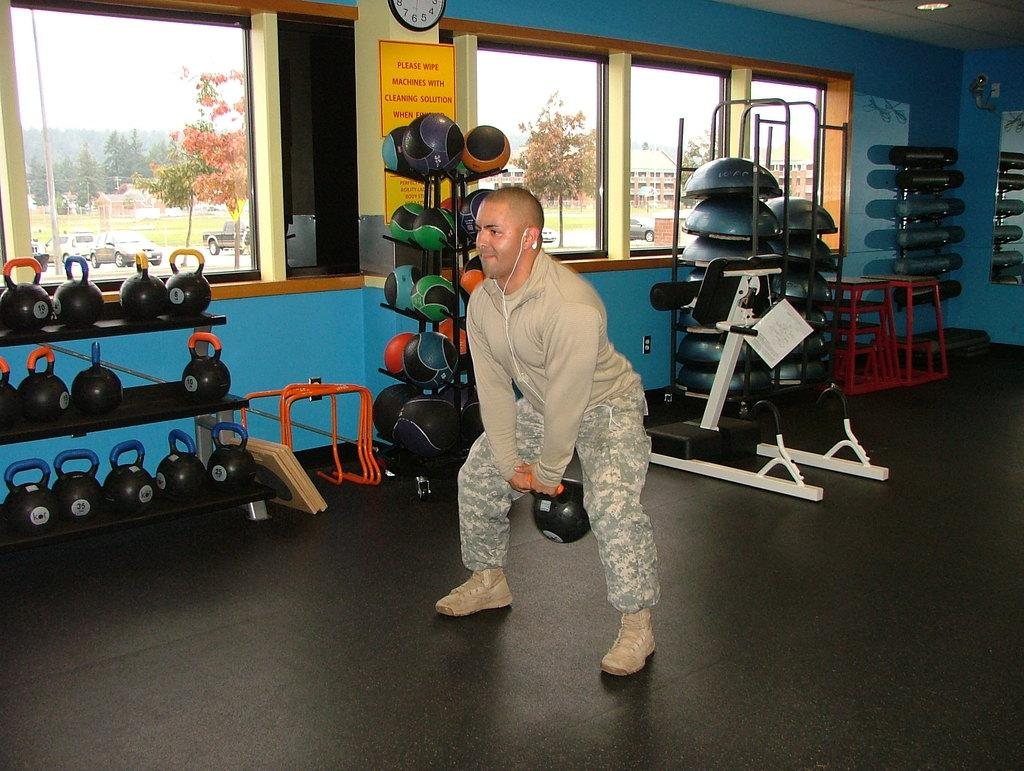<image>
Share a concise interpretation of the image provided. A man is lifting weights in a weight room and there is a sign in the room that says "Please wipe machines with cleaning solution when finished." 